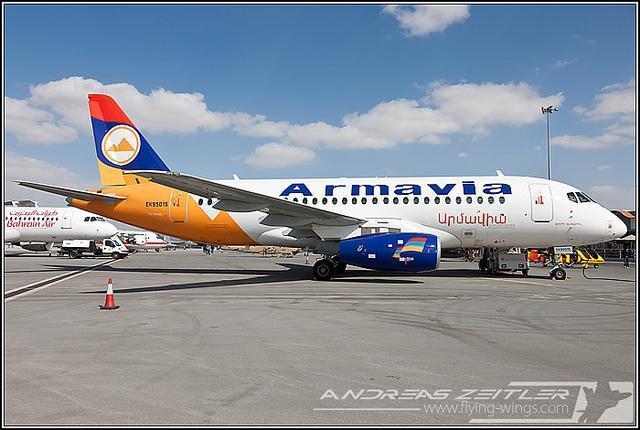How many airplanes are in the photo?
Give a very brief answer. 2. 